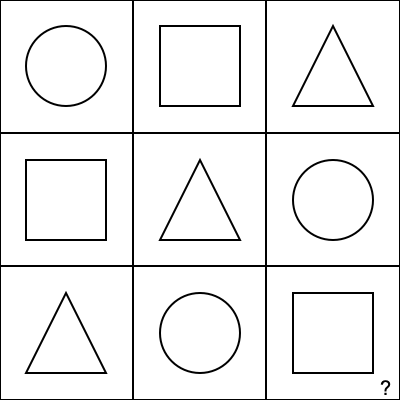Given the 3x3 grid of geometric shapes, determine the pattern and predict the shape that should replace the question mark in the bottom-right cell. Express your answer as a mathematical function $f(i, j)$ where $i$ and $j$ represent the row and column indices (0-indexed) of the grid, respectively. To solve this problem, we need to analyze the pattern in the given grid:

1. Observe that there are three distinct shapes: circle, square, and triangle.

2. Let's assign numerical values to these shapes:
   Circle: 0
   Square: 1
   Triangle: 2

3. Now, let's represent the grid as a 2D matrix of these values:

   $\begin{bmatrix}
   0 & 1 & 2 \\
   1 & 2 & 0 \\
   2 & 0 & ?
   \end{bmatrix}$

4. Analyzing the pattern, we can see that for any cell $(i, j)$, its value is the sum of its indices modulo 3:

   $f(i, j) = (i + j) \mod 3$

5. Let's verify this for known cells:
   - Top-left: $f(0, 0) = (0 + 0) \mod 3 = 0$ (Circle)
   - Middle: $f(1, 1) = (1 + 1) \mod 3 = 2$ (Triangle)
   - Bottom-left: $f(2, 0) = (2 + 0) \mod 3 = 2$ (Triangle)

6. For the missing bottom-right cell, we have:
   $f(2, 2) = (2 + 2) \mod 3 = 1$

7. The value 1 corresponds to a square.

Therefore, the function $f(i, j) = (i + j) \mod 3$ describes the pattern, and the missing shape in the bottom-right cell should be a square.
Answer: $f(i, j) = (i + j) \mod 3$; Square 